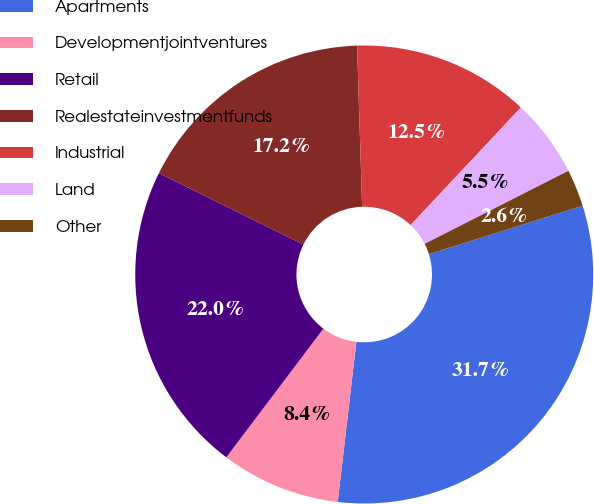Convert chart to OTSL. <chart><loc_0><loc_0><loc_500><loc_500><pie_chart><fcel>Apartments<fcel>Developmentjointventures<fcel>Retail<fcel>Realestateinvestmentfunds<fcel>Industrial<fcel>Land<fcel>Other<nl><fcel>31.71%<fcel>8.44%<fcel>22.01%<fcel>17.21%<fcel>12.49%<fcel>5.53%<fcel>2.62%<nl></chart> 